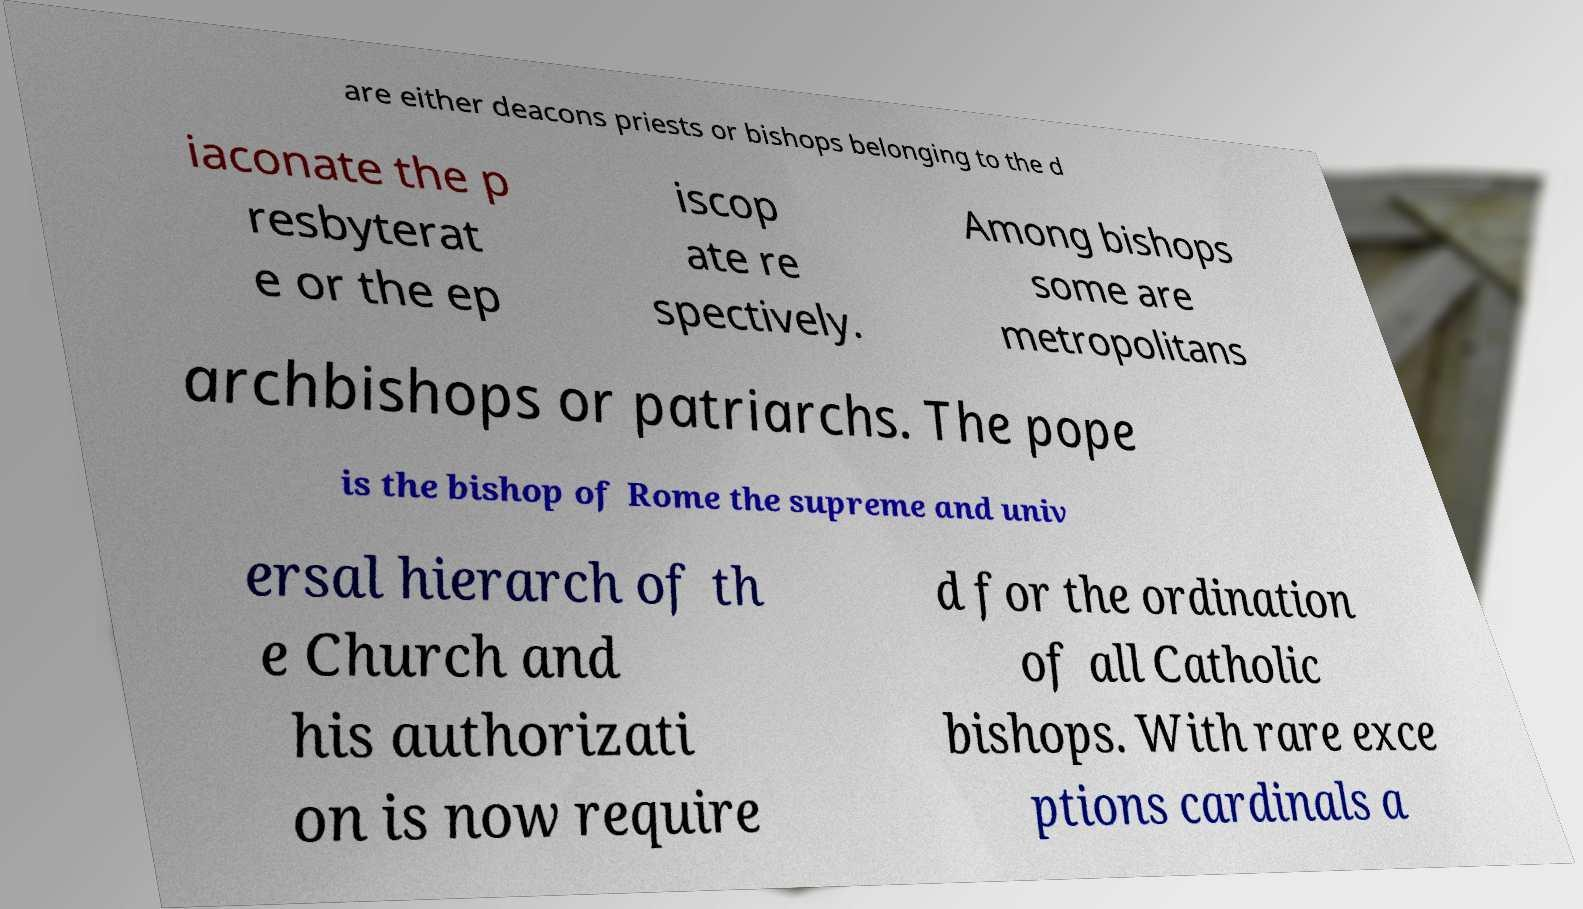Please read and relay the text visible in this image. What does it say? are either deacons priests or bishops belonging to the d iaconate the p resbyterat e or the ep iscop ate re spectively. Among bishops some are metropolitans archbishops or patriarchs. The pope is the bishop of Rome the supreme and univ ersal hierarch of th e Church and his authorizati on is now require d for the ordination of all Catholic bishops. With rare exce ptions cardinals a 